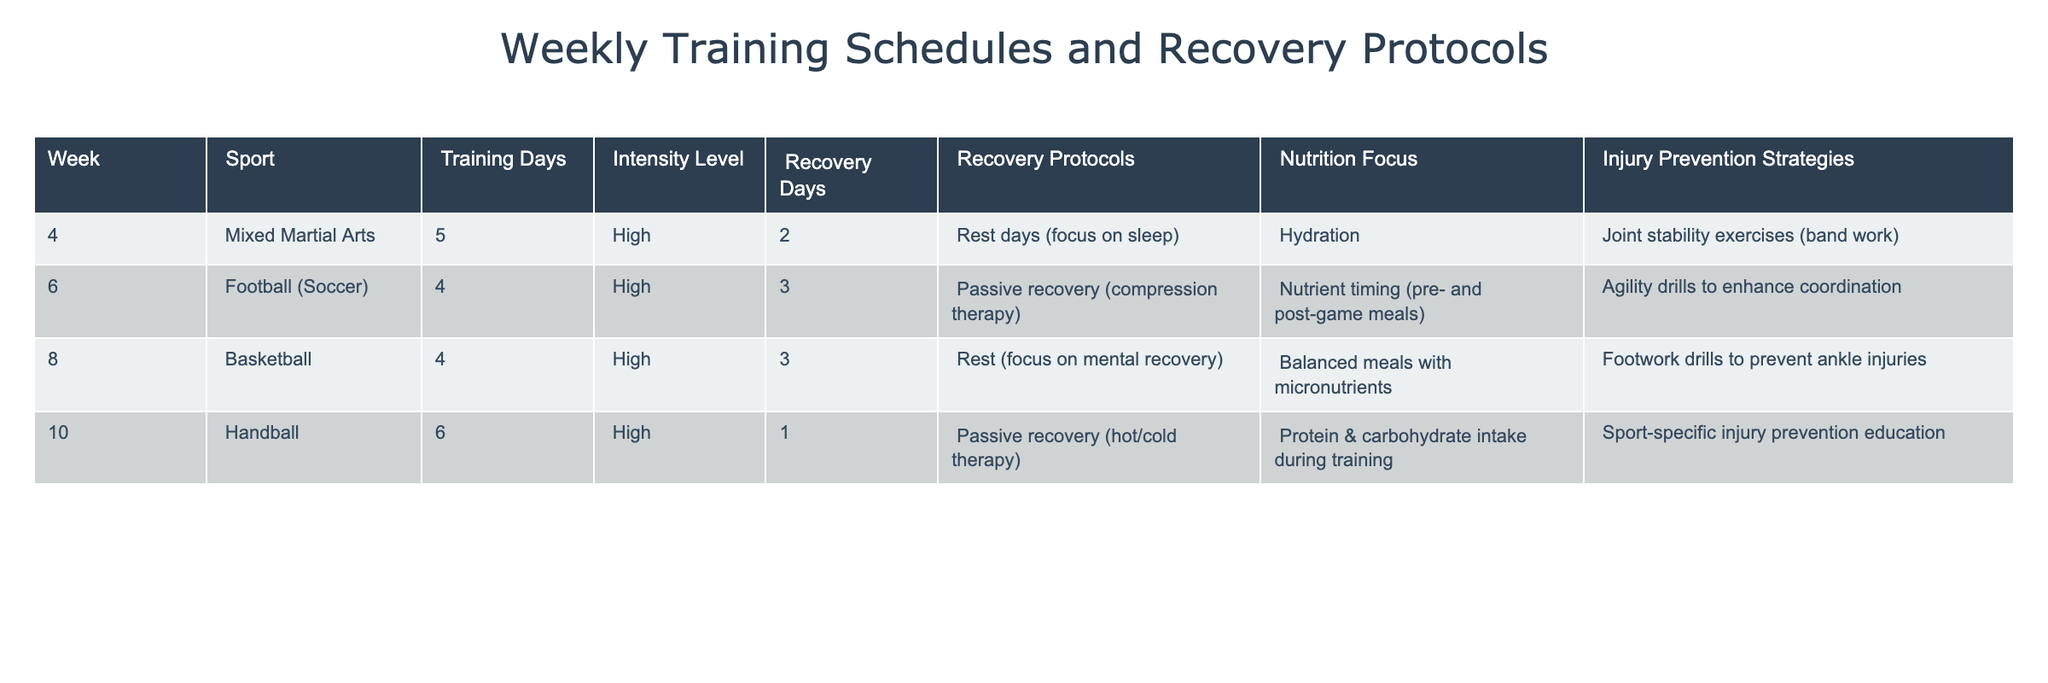What sport has the highest number of training days? The table shows that Handball has the highest number of training days, with a total of 6 days.
Answer: Handball How many recovery days are allocated for Football? The table indicates that Football has 3 recovery days listed.
Answer: 3 Which training schedule emphasizes joint stability exercises? According to the table, Mixed Martial Arts emphasizes joint stability exercises as part of its training.
Answer: Mixed Martial Arts How many sports have a high intensity level? Looking at the table, all four sports listed have a high intensity level, which means the count is 4.
Answer: 4 Is there a recovery protocol that focuses on passive recovery? Yes, both Handball and Football (Soccer) have passive recovery protocols noted in the table.
Answer: Yes What nutrition focus is recommended for Basketball? The table specifies that the nutrition focus for Basketball is on balanced meals with micronutrients.
Answer: Balanced meals with micronutrients What is the injury prevention strategy for Mixed Martial Arts? The table lists that Mixed Martial Arts uses joint stability exercises, specifically band work, as its injury prevention strategy.
Answer: Joint stability exercises (band work) If a total of 25 training days are considered for all sports, what is the average number of training days per sport? There are 4 sports, and the total training days are 5 + 4 + 4 + 6 = 19 days. Therefore, the average training days per sport is 19 / 4 = 4.75 days.
Answer: 4.75 Which sport has the least number of recovery days, and how many are allocated? According to the table, Handball has the least number of recovery days with just 1 day allocated.
Answer: Handball, 1 day What are the nutrition focuses for the different sports listed? The table outlines varying nutrition focuses: Mixed Martial Arts emphasizes hydration, Football focuses on nutrient timing, Basketball highlights balanced meals, and Handball stresses protein & carbohydrate intake.
Answer: Varies by sport Which training schedule has more recovery days, Handball or Basketball? The table shows Basketball has 3 recovery days, whereas Handball has only 1 recovery day, indicating Basketball has more.
Answer: Basketball 